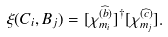Convert formula to latex. <formula><loc_0><loc_0><loc_500><loc_500>\xi ( C _ { i } , B _ { j } ) = [ \chi _ { m _ { i } } ^ { ( \widehat { b } ) } ] ^ { \dagger } [ \chi _ { m _ { j } } ^ { ( \widehat { c } ) } ] .</formula> 